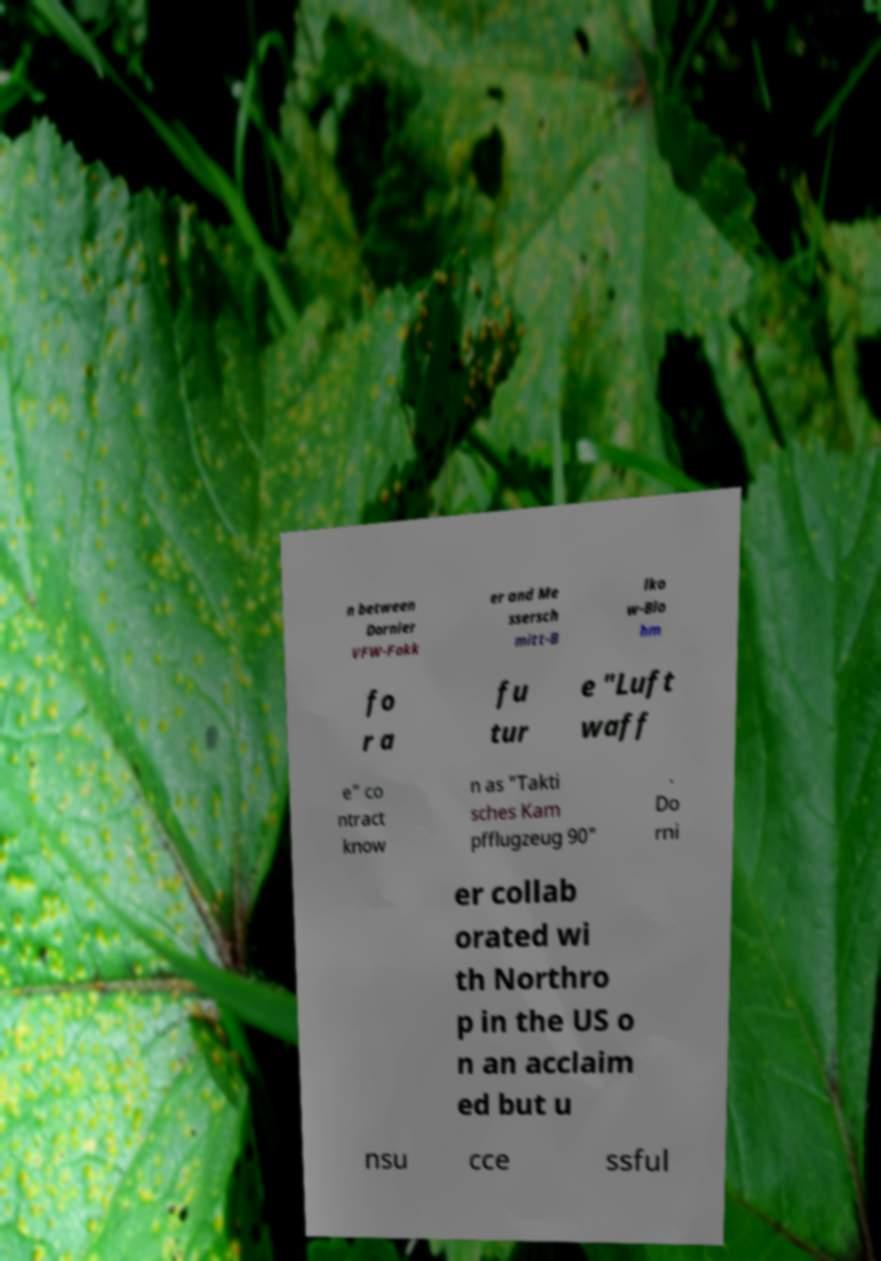There's text embedded in this image that I need extracted. Can you transcribe it verbatim? n between Dornier VFW-Fokk er and Me ssersch mitt-B lko w-Blo hm fo r a fu tur e "Luft waff e" co ntract know n as "Takti sches Kam pfflugzeug 90" . Do rni er collab orated wi th Northro p in the US o n an acclaim ed but u nsu cce ssful 